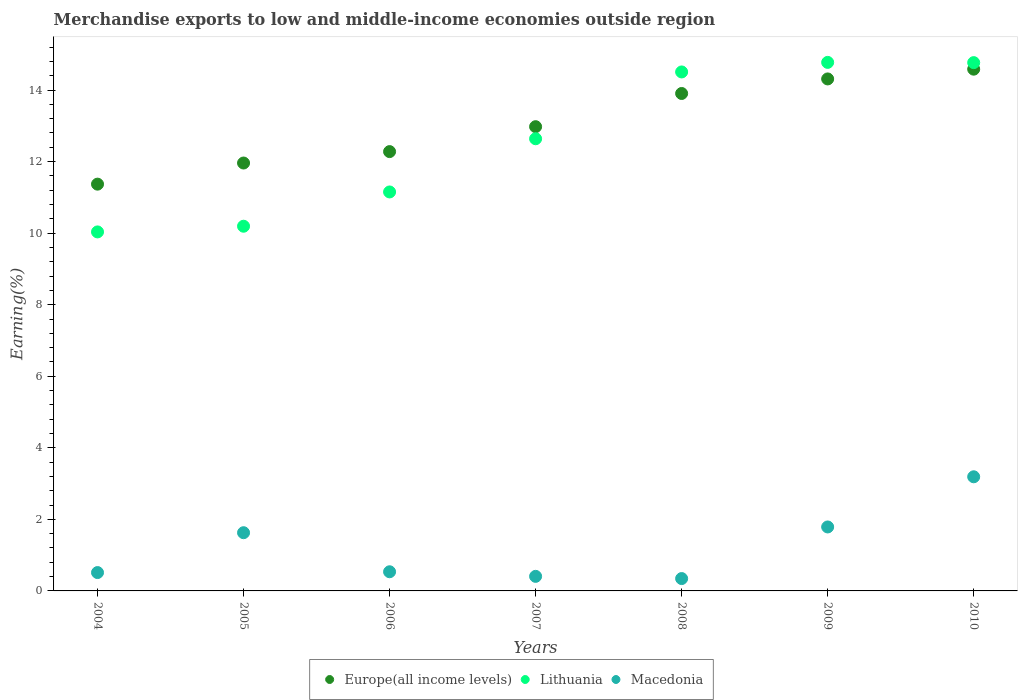How many different coloured dotlines are there?
Provide a succinct answer. 3. What is the percentage of amount earned from merchandise exports in Macedonia in 2008?
Provide a succinct answer. 0.35. Across all years, what is the maximum percentage of amount earned from merchandise exports in Europe(all income levels)?
Your response must be concise. 14.58. Across all years, what is the minimum percentage of amount earned from merchandise exports in Lithuania?
Provide a succinct answer. 10.03. What is the total percentage of amount earned from merchandise exports in Macedonia in the graph?
Your answer should be very brief. 8.41. What is the difference between the percentage of amount earned from merchandise exports in Macedonia in 2007 and that in 2010?
Offer a terse response. -2.78. What is the difference between the percentage of amount earned from merchandise exports in Macedonia in 2005 and the percentage of amount earned from merchandise exports in Lithuania in 2008?
Offer a very short reply. -12.88. What is the average percentage of amount earned from merchandise exports in Macedonia per year?
Your answer should be very brief. 1.2. In the year 2004, what is the difference between the percentage of amount earned from merchandise exports in Macedonia and percentage of amount earned from merchandise exports in Europe(all income levels)?
Your answer should be very brief. -10.86. In how many years, is the percentage of amount earned from merchandise exports in Lithuania greater than 8 %?
Give a very brief answer. 7. What is the ratio of the percentage of amount earned from merchandise exports in Macedonia in 2007 to that in 2010?
Make the answer very short. 0.13. Is the difference between the percentage of amount earned from merchandise exports in Macedonia in 2008 and 2009 greater than the difference between the percentage of amount earned from merchandise exports in Europe(all income levels) in 2008 and 2009?
Provide a short and direct response. No. What is the difference between the highest and the second highest percentage of amount earned from merchandise exports in Europe(all income levels)?
Your answer should be compact. 0.27. What is the difference between the highest and the lowest percentage of amount earned from merchandise exports in Europe(all income levels)?
Ensure brevity in your answer.  3.21. Does the percentage of amount earned from merchandise exports in Europe(all income levels) monotonically increase over the years?
Keep it short and to the point. Yes. How many years are there in the graph?
Your response must be concise. 7. Are the values on the major ticks of Y-axis written in scientific E-notation?
Your answer should be compact. No. Does the graph contain any zero values?
Make the answer very short. No. Does the graph contain grids?
Offer a terse response. No. Where does the legend appear in the graph?
Your response must be concise. Bottom center. How many legend labels are there?
Keep it short and to the point. 3. What is the title of the graph?
Offer a very short reply. Merchandise exports to low and middle-income economies outside region. What is the label or title of the X-axis?
Ensure brevity in your answer.  Years. What is the label or title of the Y-axis?
Give a very brief answer. Earning(%). What is the Earning(%) in Europe(all income levels) in 2004?
Offer a very short reply. 11.37. What is the Earning(%) in Lithuania in 2004?
Offer a terse response. 10.03. What is the Earning(%) of Macedonia in 2004?
Keep it short and to the point. 0.51. What is the Earning(%) of Europe(all income levels) in 2005?
Provide a succinct answer. 11.96. What is the Earning(%) in Lithuania in 2005?
Make the answer very short. 10.19. What is the Earning(%) in Macedonia in 2005?
Provide a succinct answer. 1.63. What is the Earning(%) in Europe(all income levels) in 2006?
Give a very brief answer. 12.28. What is the Earning(%) of Lithuania in 2006?
Your answer should be compact. 11.15. What is the Earning(%) of Macedonia in 2006?
Make the answer very short. 0.54. What is the Earning(%) in Europe(all income levels) in 2007?
Make the answer very short. 12.98. What is the Earning(%) of Lithuania in 2007?
Provide a short and direct response. 12.64. What is the Earning(%) of Macedonia in 2007?
Your answer should be very brief. 0.41. What is the Earning(%) in Europe(all income levels) in 2008?
Offer a terse response. 13.9. What is the Earning(%) of Lithuania in 2008?
Your answer should be compact. 14.51. What is the Earning(%) of Macedonia in 2008?
Keep it short and to the point. 0.35. What is the Earning(%) of Europe(all income levels) in 2009?
Give a very brief answer. 14.31. What is the Earning(%) of Lithuania in 2009?
Offer a terse response. 14.77. What is the Earning(%) of Macedonia in 2009?
Your answer should be very brief. 1.79. What is the Earning(%) of Europe(all income levels) in 2010?
Your response must be concise. 14.58. What is the Earning(%) in Lithuania in 2010?
Your answer should be very brief. 14.77. What is the Earning(%) of Macedonia in 2010?
Give a very brief answer. 3.19. Across all years, what is the maximum Earning(%) in Europe(all income levels)?
Your answer should be very brief. 14.58. Across all years, what is the maximum Earning(%) in Lithuania?
Your answer should be compact. 14.77. Across all years, what is the maximum Earning(%) in Macedonia?
Provide a succinct answer. 3.19. Across all years, what is the minimum Earning(%) of Europe(all income levels)?
Your response must be concise. 11.37. Across all years, what is the minimum Earning(%) in Lithuania?
Provide a succinct answer. 10.03. Across all years, what is the minimum Earning(%) of Macedonia?
Provide a short and direct response. 0.35. What is the total Earning(%) of Europe(all income levels) in the graph?
Your answer should be very brief. 91.38. What is the total Earning(%) in Lithuania in the graph?
Offer a terse response. 88.06. What is the total Earning(%) in Macedonia in the graph?
Offer a terse response. 8.41. What is the difference between the Earning(%) in Europe(all income levels) in 2004 and that in 2005?
Provide a succinct answer. -0.59. What is the difference between the Earning(%) in Lithuania in 2004 and that in 2005?
Your response must be concise. -0.16. What is the difference between the Earning(%) in Macedonia in 2004 and that in 2005?
Your answer should be compact. -1.11. What is the difference between the Earning(%) of Europe(all income levels) in 2004 and that in 2006?
Offer a terse response. -0.91. What is the difference between the Earning(%) of Lithuania in 2004 and that in 2006?
Your answer should be very brief. -1.12. What is the difference between the Earning(%) in Macedonia in 2004 and that in 2006?
Provide a succinct answer. -0.02. What is the difference between the Earning(%) of Europe(all income levels) in 2004 and that in 2007?
Provide a succinct answer. -1.61. What is the difference between the Earning(%) of Lithuania in 2004 and that in 2007?
Keep it short and to the point. -2.6. What is the difference between the Earning(%) in Macedonia in 2004 and that in 2007?
Ensure brevity in your answer.  0.11. What is the difference between the Earning(%) in Europe(all income levels) in 2004 and that in 2008?
Offer a very short reply. -2.53. What is the difference between the Earning(%) of Lithuania in 2004 and that in 2008?
Provide a short and direct response. -4.47. What is the difference between the Earning(%) in Macedonia in 2004 and that in 2008?
Provide a succinct answer. 0.17. What is the difference between the Earning(%) of Europe(all income levels) in 2004 and that in 2009?
Make the answer very short. -2.94. What is the difference between the Earning(%) in Lithuania in 2004 and that in 2009?
Provide a short and direct response. -4.74. What is the difference between the Earning(%) of Macedonia in 2004 and that in 2009?
Give a very brief answer. -1.27. What is the difference between the Earning(%) in Europe(all income levels) in 2004 and that in 2010?
Provide a short and direct response. -3.21. What is the difference between the Earning(%) of Lithuania in 2004 and that in 2010?
Offer a very short reply. -4.73. What is the difference between the Earning(%) in Macedonia in 2004 and that in 2010?
Provide a succinct answer. -2.68. What is the difference between the Earning(%) of Europe(all income levels) in 2005 and that in 2006?
Your answer should be very brief. -0.32. What is the difference between the Earning(%) of Lithuania in 2005 and that in 2006?
Keep it short and to the point. -0.96. What is the difference between the Earning(%) of Macedonia in 2005 and that in 2006?
Offer a very short reply. 1.09. What is the difference between the Earning(%) in Europe(all income levels) in 2005 and that in 2007?
Keep it short and to the point. -1.02. What is the difference between the Earning(%) of Lithuania in 2005 and that in 2007?
Offer a very short reply. -2.44. What is the difference between the Earning(%) in Macedonia in 2005 and that in 2007?
Your answer should be compact. 1.22. What is the difference between the Earning(%) of Europe(all income levels) in 2005 and that in 2008?
Provide a succinct answer. -1.94. What is the difference between the Earning(%) of Lithuania in 2005 and that in 2008?
Offer a very short reply. -4.31. What is the difference between the Earning(%) of Macedonia in 2005 and that in 2008?
Make the answer very short. 1.28. What is the difference between the Earning(%) in Europe(all income levels) in 2005 and that in 2009?
Keep it short and to the point. -2.35. What is the difference between the Earning(%) of Lithuania in 2005 and that in 2009?
Provide a succinct answer. -4.58. What is the difference between the Earning(%) in Macedonia in 2005 and that in 2009?
Your response must be concise. -0.16. What is the difference between the Earning(%) in Europe(all income levels) in 2005 and that in 2010?
Keep it short and to the point. -2.62. What is the difference between the Earning(%) of Lithuania in 2005 and that in 2010?
Offer a terse response. -4.57. What is the difference between the Earning(%) in Macedonia in 2005 and that in 2010?
Ensure brevity in your answer.  -1.56. What is the difference between the Earning(%) in Europe(all income levels) in 2006 and that in 2007?
Your response must be concise. -0.7. What is the difference between the Earning(%) of Lithuania in 2006 and that in 2007?
Make the answer very short. -1.49. What is the difference between the Earning(%) of Macedonia in 2006 and that in 2007?
Offer a very short reply. 0.13. What is the difference between the Earning(%) of Europe(all income levels) in 2006 and that in 2008?
Keep it short and to the point. -1.62. What is the difference between the Earning(%) in Lithuania in 2006 and that in 2008?
Make the answer very short. -3.35. What is the difference between the Earning(%) of Macedonia in 2006 and that in 2008?
Give a very brief answer. 0.19. What is the difference between the Earning(%) of Europe(all income levels) in 2006 and that in 2009?
Your response must be concise. -2.03. What is the difference between the Earning(%) in Lithuania in 2006 and that in 2009?
Your response must be concise. -3.62. What is the difference between the Earning(%) in Macedonia in 2006 and that in 2009?
Offer a very short reply. -1.25. What is the difference between the Earning(%) of Europe(all income levels) in 2006 and that in 2010?
Your response must be concise. -2.3. What is the difference between the Earning(%) in Lithuania in 2006 and that in 2010?
Keep it short and to the point. -3.61. What is the difference between the Earning(%) in Macedonia in 2006 and that in 2010?
Make the answer very short. -2.65. What is the difference between the Earning(%) of Europe(all income levels) in 2007 and that in 2008?
Your answer should be compact. -0.93. What is the difference between the Earning(%) in Lithuania in 2007 and that in 2008?
Give a very brief answer. -1.87. What is the difference between the Earning(%) in Macedonia in 2007 and that in 2008?
Your answer should be compact. 0.06. What is the difference between the Earning(%) in Europe(all income levels) in 2007 and that in 2009?
Provide a short and direct response. -1.33. What is the difference between the Earning(%) of Lithuania in 2007 and that in 2009?
Make the answer very short. -2.13. What is the difference between the Earning(%) in Macedonia in 2007 and that in 2009?
Offer a very short reply. -1.38. What is the difference between the Earning(%) in Europe(all income levels) in 2007 and that in 2010?
Ensure brevity in your answer.  -1.61. What is the difference between the Earning(%) in Lithuania in 2007 and that in 2010?
Give a very brief answer. -2.13. What is the difference between the Earning(%) in Macedonia in 2007 and that in 2010?
Your response must be concise. -2.78. What is the difference between the Earning(%) in Europe(all income levels) in 2008 and that in 2009?
Your response must be concise. -0.41. What is the difference between the Earning(%) of Lithuania in 2008 and that in 2009?
Your answer should be very brief. -0.27. What is the difference between the Earning(%) in Macedonia in 2008 and that in 2009?
Provide a succinct answer. -1.44. What is the difference between the Earning(%) in Europe(all income levels) in 2008 and that in 2010?
Your answer should be very brief. -0.68. What is the difference between the Earning(%) in Lithuania in 2008 and that in 2010?
Give a very brief answer. -0.26. What is the difference between the Earning(%) of Macedonia in 2008 and that in 2010?
Provide a succinct answer. -2.84. What is the difference between the Earning(%) in Europe(all income levels) in 2009 and that in 2010?
Your response must be concise. -0.27. What is the difference between the Earning(%) of Lithuania in 2009 and that in 2010?
Provide a succinct answer. 0.01. What is the difference between the Earning(%) of Macedonia in 2009 and that in 2010?
Make the answer very short. -1.4. What is the difference between the Earning(%) in Europe(all income levels) in 2004 and the Earning(%) in Lithuania in 2005?
Provide a succinct answer. 1.18. What is the difference between the Earning(%) of Europe(all income levels) in 2004 and the Earning(%) of Macedonia in 2005?
Give a very brief answer. 9.74. What is the difference between the Earning(%) of Lithuania in 2004 and the Earning(%) of Macedonia in 2005?
Provide a succinct answer. 8.41. What is the difference between the Earning(%) of Europe(all income levels) in 2004 and the Earning(%) of Lithuania in 2006?
Ensure brevity in your answer.  0.22. What is the difference between the Earning(%) in Europe(all income levels) in 2004 and the Earning(%) in Macedonia in 2006?
Your answer should be compact. 10.83. What is the difference between the Earning(%) of Lithuania in 2004 and the Earning(%) of Macedonia in 2006?
Your answer should be very brief. 9.5. What is the difference between the Earning(%) in Europe(all income levels) in 2004 and the Earning(%) in Lithuania in 2007?
Offer a very short reply. -1.27. What is the difference between the Earning(%) of Europe(all income levels) in 2004 and the Earning(%) of Macedonia in 2007?
Offer a very short reply. 10.96. What is the difference between the Earning(%) in Lithuania in 2004 and the Earning(%) in Macedonia in 2007?
Ensure brevity in your answer.  9.63. What is the difference between the Earning(%) of Europe(all income levels) in 2004 and the Earning(%) of Lithuania in 2008?
Give a very brief answer. -3.14. What is the difference between the Earning(%) of Europe(all income levels) in 2004 and the Earning(%) of Macedonia in 2008?
Offer a very short reply. 11.02. What is the difference between the Earning(%) in Lithuania in 2004 and the Earning(%) in Macedonia in 2008?
Offer a terse response. 9.69. What is the difference between the Earning(%) of Europe(all income levels) in 2004 and the Earning(%) of Lithuania in 2009?
Keep it short and to the point. -3.4. What is the difference between the Earning(%) of Europe(all income levels) in 2004 and the Earning(%) of Macedonia in 2009?
Offer a terse response. 9.58. What is the difference between the Earning(%) in Lithuania in 2004 and the Earning(%) in Macedonia in 2009?
Keep it short and to the point. 8.25. What is the difference between the Earning(%) in Europe(all income levels) in 2004 and the Earning(%) in Lithuania in 2010?
Keep it short and to the point. -3.4. What is the difference between the Earning(%) of Europe(all income levels) in 2004 and the Earning(%) of Macedonia in 2010?
Your answer should be very brief. 8.18. What is the difference between the Earning(%) in Lithuania in 2004 and the Earning(%) in Macedonia in 2010?
Your answer should be compact. 6.84. What is the difference between the Earning(%) in Europe(all income levels) in 2005 and the Earning(%) in Lithuania in 2006?
Your answer should be very brief. 0.81. What is the difference between the Earning(%) of Europe(all income levels) in 2005 and the Earning(%) of Macedonia in 2006?
Ensure brevity in your answer.  11.42. What is the difference between the Earning(%) of Lithuania in 2005 and the Earning(%) of Macedonia in 2006?
Offer a terse response. 9.66. What is the difference between the Earning(%) in Europe(all income levels) in 2005 and the Earning(%) in Lithuania in 2007?
Keep it short and to the point. -0.68. What is the difference between the Earning(%) of Europe(all income levels) in 2005 and the Earning(%) of Macedonia in 2007?
Ensure brevity in your answer.  11.55. What is the difference between the Earning(%) in Lithuania in 2005 and the Earning(%) in Macedonia in 2007?
Keep it short and to the point. 9.79. What is the difference between the Earning(%) of Europe(all income levels) in 2005 and the Earning(%) of Lithuania in 2008?
Your response must be concise. -2.55. What is the difference between the Earning(%) of Europe(all income levels) in 2005 and the Earning(%) of Macedonia in 2008?
Provide a short and direct response. 11.61. What is the difference between the Earning(%) of Lithuania in 2005 and the Earning(%) of Macedonia in 2008?
Provide a short and direct response. 9.85. What is the difference between the Earning(%) of Europe(all income levels) in 2005 and the Earning(%) of Lithuania in 2009?
Ensure brevity in your answer.  -2.81. What is the difference between the Earning(%) of Europe(all income levels) in 2005 and the Earning(%) of Macedonia in 2009?
Make the answer very short. 10.17. What is the difference between the Earning(%) in Lithuania in 2005 and the Earning(%) in Macedonia in 2009?
Your answer should be very brief. 8.41. What is the difference between the Earning(%) in Europe(all income levels) in 2005 and the Earning(%) in Lithuania in 2010?
Your response must be concise. -2.81. What is the difference between the Earning(%) in Europe(all income levels) in 2005 and the Earning(%) in Macedonia in 2010?
Provide a short and direct response. 8.77. What is the difference between the Earning(%) in Lithuania in 2005 and the Earning(%) in Macedonia in 2010?
Provide a succinct answer. 7. What is the difference between the Earning(%) in Europe(all income levels) in 2006 and the Earning(%) in Lithuania in 2007?
Offer a terse response. -0.36. What is the difference between the Earning(%) in Europe(all income levels) in 2006 and the Earning(%) in Macedonia in 2007?
Offer a very short reply. 11.87. What is the difference between the Earning(%) of Lithuania in 2006 and the Earning(%) of Macedonia in 2007?
Keep it short and to the point. 10.74. What is the difference between the Earning(%) in Europe(all income levels) in 2006 and the Earning(%) in Lithuania in 2008?
Your response must be concise. -2.23. What is the difference between the Earning(%) in Europe(all income levels) in 2006 and the Earning(%) in Macedonia in 2008?
Make the answer very short. 11.93. What is the difference between the Earning(%) of Lithuania in 2006 and the Earning(%) of Macedonia in 2008?
Give a very brief answer. 10.81. What is the difference between the Earning(%) of Europe(all income levels) in 2006 and the Earning(%) of Lithuania in 2009?
Offer a very short reply. -2.49. What is the difference between the Earning(%) in Europe(all income levels) in 2006 and the Earning(%) in Macedonia in 2009?
Your answer should be very brief. 10.49. What is the difference between the Earning(%) of Lithuania in 2006 and the Earning(%) of Macedonia in 2009?
Ensure brevity in your answer.  9.36. What is the difference between the Earning(%) of Europe(all income levels) in 2006 and the Earning(%) of Lithuania in 2010?
Provide a succinct answer. -2.49. What is the difference between the Earning(%) of Europe(all income levels) in 2006 and the Earning(%) of Macedonia in 2010?
Offer a terse response. 9.09. What is the difference between the Earning(%) of Lithuania in 2006 and the Earning(%) of Macedonia in 2010?
Your response must be concise. 7.96. What is the difference between the Earning(%) of Europe(all income levels) in 2007 and the Earning(%) of Lithuania in 2008?
Offer a terse response. -1.53. What is the difference between the Earning(%) of Europe(all income levels) in 2007 and the Earning(%) of Macedonia in 2008?
Provide a short and direct response. 12.63. What is the difference between the Earning(%) of Lithuania in 2007 and the Earning(%) of Macedonia in 2008?
Your answer should be compact. 12.29. What is the difference between the Earning(%) of Europe(all income levels) in 2007 and the Earning(%) of Lithuania in 2009?
Make the answer very short. -1.8. What is the difference between the Earning(%) in Europe(all income levels) in 2007 and the Earning(%) in Macedonia in 2009?
Provide a short and direct response. 11.19. What is the difference between the Earning(%) in Lithuania in 2007 and the Earning(%) in Macedonia in 2009?
Offer a very short reply. 10.85. What is the difference between the Earning(%) in Europe(all income levels) in 2007 and the Earning(%) in Lithuania in 2010?
Your response must be concise. -1.79. What is the difference between the Earning(%) of Europe(all income levels) in 2007 and the Earning(%) of Macedonia in 2010?
Offer a terse response. 9.79. What is the difference between the Earning(%) of Lithuania in 2007 and the Earning(%) of Macedonia in 2010?
Ensure brevity in your answer.  9.45. What is the difference between the Earning(%) of Europe(all income levels) in 2008 and the Earning(%) of Lithuania in 2009?
Your answer should be compact. -0.87. What is the difference between the Earning(%) in Europe(all income levels) in 2008 and the Earning(%) in Macedonia in 2009?
Ensure brevity in your answer.  12.12. What is the difference between the Earning(%) in Lithuania in 2008 and the Earning(%) in Macedonia in 2009?
Provide a succinct answer. 12.72. What is the difference between the Earning(%) in Europe(all income levels) in 2008 and the Earning(%) in Lithuania in 2010?
Give a very brief answer. -0.86. What is the difference between the Earning(%) of Europe(all income levels) in 2008 and the Earning(%) of Macedonia in 2010?
Your response must be concise. 10.71. What is the difference between the Earning(%) in Lithuania in 2008 and the Earning(%) in Macedonia in 2010?
Your answer should be very brief. 11.31. What is the difference between the Earning(%) of Europe(all income levels) in 2009 and the Earning(%) of Lithuania in 2010?
Your answer should be compact. -0.46. What is the difference between the Earning(%) of Europe(all income levels) in 2009 and the Earning(%) of Macedonia in 2010?
Your answer should be very brief. 11.12. What is the difference between the Earning(%) in Lithuania in 2009 and the Earning(%) in Macedonia in 2010?
Give a very brief answer. 11.58. What is the average Earning(%) in Europe(all income levels) per year?
Provide a succinct answer. 13.05. What is the average Earning(%) in Lithuania per year?
Ensure brevity in your answer.  12.58. What is the average Earning(%) of Macedonia per year?
Keep it short and to the point. 1.2. In the year 2004, what is the difference between the Earning(%) of Europe(all income levels) and Earning(%) of Lithuania?
Provide a short and direct response. 1.33. In the year 2004, what is the difference between the Earning(%) of Europe(all income levels) and Earning(%) of Macedonia?
Provide a short and direct response. 10.86. In the year 2004, what is the difference between the Earning(%) in Lithuania and Earning(%) in Macedonia?
Keep it short and to the point. 9.52. In the year 2005, what is the difference between the Earning(%) of Europe(all income levels) and Earning(%) of Lithuania?
Give a very brief answer. 1.77. In the year 2005, what is the difference between the Earning(%) in Europe(all income levels) and Earning(%) in Macedonia?
Keep it short and to the point. 10.33. In the year 2005, what is the difference between the Earning(%) of Lithuania and Earning(%) of Macedonia?
Offer a terse response. 8.57. In the year 2006, what is the difference between the Earning(%) in Europe(all income levels) and Earning(%) in Lithuania?
Ensure brevity in your answer.  1.13. In the year 2006, what is the difference between the Earning(%) in Europe(all income levels) and Earning(%) in Macedonia?
Offer a terse response. 11.74. In the year 2006, what is the difference between the Earning(%) of Lithuania and Earning(%) of Macedonia?
Keep it short and to the point. 10.62. In the year 2007, what is the difference between the Earning(%) in Europe(all income levels) and Earning(%) in Lithuania?
Give a very brief answer. 0.34. In the year 2007, what is the difference between the Earning(%) of Europe(all income levels) and Earning(%) of Macedonia?
Provide a short and direct response. 12.57. In the year 2007, what is the difference between the Earning(%) of Lithuania and Earning(%) of Macedonia?
Provide a short and direct response. 12.23. In the year 2008, what is the difference between the Earning(%) of Europe(all income levels) and Earning(%) of Lithuania?
Give a very brief answer. -0.6. In the year 2008, what is the difference between the Earning(%) in Europe(all income levels) and Earning(%) in Macedonia?
Make the answer very short. 13.56. In the year 2008, what is the difference between the Earning(%) in Lithuania and Earning(%) in Macedonia?
Provide a succinct answer. 14.16. In the year 2009, what is the difference between the Earning(%) of Europe(all income levels) and Earning(%) of Lithuania?
Give a very brief answer. -0.46. In the year 2009, what is the difference between the Earning(%) in Europe(all income levels) and Earning(%) in Macedonia?
Give a very brief answer. 12.52. In the year 2009, what is the difference between the Earning(%) in Lithuania and Earning(%) in Macedonia?
Your answer should be compact. 12.98. In the year 2010, what is the difference between the Earning(%) in Europe(all income levels) and Earning(%) in Lithuania?
Ensure brevity in your answer.  -0.18. In the year 2010, what is the difference between the Earning(%) in Europe(all income levels) and Earning(%) in Macedonia?
Make the answer very short. 11.39. In the year 2010, what is the difference between the Earning(%) in Lithuania and Earning(%) in Macedonia?
Give a very brief answer. 11.58. What is the ratio of the Earning(%) in Europe(all income levels) in 2004 to that in 2005?
Your answer should be very brief. 0.95. What is the ratio of the Earning(%) of Lithuania in 2004 to that in 2005?
Ensure brevity in your answer.  0.98. What is the ratio of the Earning(%) of Macedonia in 2004 to that in 2005?
Offer a very short reply. 0.32. What is the ratio of the Earning(%) of Europe(all income levels) in 2004 to that in 2006?
Your answer should be very brief. 0.93. What is the ratio of the Earning(%) of Lithuania in 2004 to that in 2006?
Ensure brevity in your answer.  0.9. What is the ratio of the Earning(%) in Macedonia in 2004 to that in 2006?
Offer a very short reply. 0.96. What is the ratio of the Earning(%) of Europe(all income levels) in 2004 to that in 2007?
Provide a succinct answer. 0.88. What is the ratio of the Earning(%) of Lithuania in 2004 to that in 2007?
Your answer should be compact. 0.79. What is the ratio of the Earning(%) in Macedonia in 2004 to that in 2007?
Your answer should be very brief. 1.26. What is the ratio of the Earning(%) of Europe(all income levels) in 2004 to that in 2008?
Your response must be concise. 0.82. What is the ratio of the Earning(%) of Lithuania in 2004 to that in 2008?
Your answer should be very brief. 0.69. What is the ratio of the Earning(%) in Macedonia in 2004 to that in 2008?
Offer a terse response. 1.49. What is the ratio of the Earning(%) in Europe(all income levels) in 2004 to that in 2009?
Ensure brevity in your answer.  0.79. What is the ratio of the Earning(%) of Lithuania in 2004 to that in 2009?
Your answer should be compact. 0.68. What is the ratio of the Earning(%) of Macedonia in 2004 to that in 2009?
Ensure brevity in your answer.  0.29. What is the ratio of the Earning(%) in Europe(all income levels) in 2004 to that in 2010?
Your answer should be compact. 0.78. What is the ratio of the Earning(%) of Lithuania in 2004 to that in 2010?
Ensure brevity in your answer.  0.68. What is the ratio of the Earning(%) in Macedonia in 2004 to that in 2010?
Give a very brief answer. 0.16. What is the ratio of the Earning(%) of Europe(all income levels) in 2005 to that in 2006?
Ensure brevity in your answer.  0.97. What is the ratio of the Earning(%) in Lithuania in 2005 to that in 2006?
Give a very brief answer. 0.91. What is the ratio of the Earning(%) of Macedonia in 2005 to that in 2006?
Offer a terse response. 3.04. What is the ratio of the Earning(%) of Europe(all income levels) in 2005 to that in 2007?
Your answer should be compact. 0.92. What is the ratio of the Earning(%) of Lithuania in 2005 to that in 2007?
Keep it short and to the point. 0.81. What is the ratio of the Earning(%) of Macedonia in 2005 to that in 2007?
Offer a very short reply. 4. What is the ratio of the Earning(%) of Europe(all income levels) in 2005 to that in 2008?
Your answer should be very brief. 0.86. What is the ratio of the Earning(%) in Lithuania in 2005 to that in 2008?
Keep it short and to the point. 0.7. What is the ratio of the Earning(%) in Macedonia in 2005 to that in 2008?
Offer a terse response. 4.71. What is the ratio of the Earning(%) of Europe(all income levels) in 2005 to that in 2009?
Provide a short and direct response. 0.84. What is the ratio of the Earning(%) in Lithuania in 2005 to that in 2009?
Give a very brief answer. 0.69. What is the ratio of the Earning(%) in Macedonia in 2005 to that in 2009?
Ensure brevity in your answer.  0.91. What is the ratio of the Earning(%) of Europe(all income levels) in 2005 to that in 2010?
Your answer should be compact. 0.82. What is the ratio of the Earning(%) in Lithuania in 2005 to that in 2010?
Make the answer very short. 0.69. What is the ratio of the Earning(%) in Macedonia in 2005 to that in 2010?
Your response must be concise. 0.51. What is the ratio of the Earning(%) of Europe(all income levels) in 2006 to that in 2007?
Ensure brevity in your answer.  0.95. What is the ratio of the Earning(%) of Lithuania in 2006 to that in 2007?
Give a very brief answer. 0.88. What is the ratio of the Earning(%) of Macedonia in 2006 to that in 2007?
Offer a terse response. 1.32. What is the ratio of the Earning(%) of Europe(all income levels) in 2006 to that in 2008?
Your response must be concise. 0.88. What is the ratio of the Earning(%) in Lithuania in 2006 to that in 2008?
Ensure brevity in your answer.  0.77. What is the ratio of the Earning(%) of Macedonia in 2006 to that in 2008?
Ensure brevity in your answer.  1.55. What is the ratio of the Earning(%) of Europe(all income levels) in 2006 to that in 2009?
Your answer should be very brief. 0.86. What is the ratio of the Earning(%) in Lithuania in 2006 to that in 2009?
Offer a terse response. 0.75. What is the ratio of the Earning(%) of Macedonia in 2006 to that in 2009?
Offer a terse response. 0.3. What is the ratio of the Earning(%) of Europe(all income levels) in 2006 to that in 2010?
Make the answer very short. 0.84. What is the ratio of the Earning(%) in Lithuania in 2006 to that in 2010?
Provide a succinct answer. 0.76. What is the ratio of the Earning(%) of Macedonia in 2006 to that in 2010?
Your answer should be very brief. 0.17. What is the ratio of the Earning(%) in Europe(all income levels) in 2007 to that in 2008?
Ensure brevity in your answer.  0.93. What is the ratio of the Earning(%) of Lithuania in 2007 to that in 2008?
Offer a terse response. 0.87. What is the ratio of the Earning(%) of Macedonia in 2007 to that in 2008?
Keep it short and to the point. 1.18. What is the ratio of the Earning(%) in Europe(all income levels) in 2007 to that in 2009?
Offer a very short reply. 0.91. What is the ratio of the Earning(%) of Lithuania in 2007 to that in 2009?
Your answer should be very brief. 0.86. What is the ratio of the Earning(%) of Macedonia in 2007 to that in 2009?
Offer a terse response. 0.23. What is the ratio of the Earning(%) in Europe(all income levels) in 2007 to that in 2010?
Provide a short and direct response. 0.89. What is the ratio of the Earning(%) in Lithuania in 2007 to that in 2010?
Ensure brevity in your answer.  0.86. What is the ratio of the Earning(%) of Macedonia in 2007 to that in 2010?
Provide a succinct answer. 0.13. What is the ratio of the Earning(%) of Europe(all income levels) in 2008 to that in 2009?
Ensure brevity in your answer.  0.97. What is the ratio of the Earning(%) in Lithuania in 2008 to that in 2009?
Your answer should be compact. 0.98. What is the ratio of the Earning(%) of Macedonia in 2008 to that in 2009?
Offer a terse response. 0.19. What is the ratio of the Earning(%) of Europe(all income levels) in 2008 to that in 2010?
Provide a short and direct response. 0.95. What is the ratio of the Earning(%) of Lithuania in 2008 to that in 2010?
Make the answer very short. 0.98. What is the ratio of the Earning(%) in Macedonia in 2008 to that in 2010?
Your answer should be very brief. 0.11. What is the ratio of the Earning(%) in Europe(all income levels) in 2009 to that in 2010?
Provide a short and direct response. 0.98. What is the ratio of the Earning(%) of Lithuania in 2009 to that in 2010?
Offer a terse response. 1. What is the ratio of the Earning(%) in Macedonia in 2009 to that in 2010?
Ensure brevity in your answer.  0.56. What is the difference between the highest and the second highest Earning(%) of Europe(all income levels)?
Offer a terse response. 0.27. What is the difference between the highest and the second highest Earning(%) of Lithuania?
Provide a short and direct response. 0.01. What is the difference between the highest and the second highest Earning(%) in Macedonia?
Ensure brevity in your answer.  1.4. What is the difference between the highest and the lowest Earning(%) of Europe(all income levels)?
Keep it short and to the point. 3.21. What is the difference between the highest and the lowest Earning(%) in Lithuania?
Offer a very short reply. 4.74. What is the difference between the highest and the lowest Earning(%) in Macedonia?
Your answer should be very brief. 2.84. 